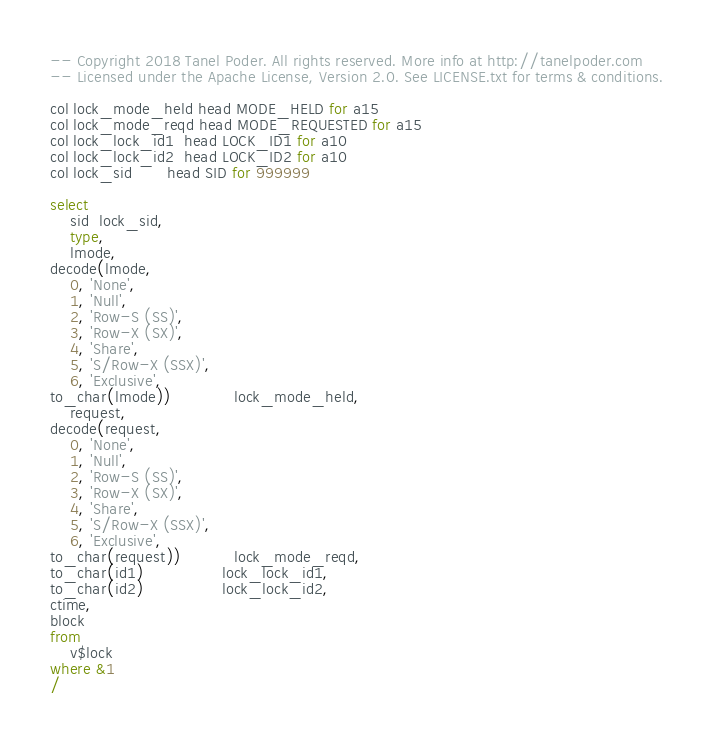Convert code to text. <code><loc_0><loc_0><loc_500><loc_500><_SQL_>-- Copyright 2018 Tanel Poder. All rights reserved. More info at http://tanelpoder.com
-- Licensed under the Apache License, Version 2.0. See LICENSE.txt for terms & conditions.

col lock_mode_held head MODE_HELD for a15
col lock_mode_reqd head MODE_REQUESTED for a15
col lock_lock_id1  head LOCK_ID1 for a10
col lock_lock_id2  head LOCK_ID2 for a10
col lock_sid       head SID for 999999

select 
    sid  lock_sid,
    type,
    lmode,
decode(lmode,
    0, 'None',           
    1, 'Null',           
    2, 'Row-S (SS)',     
    3, 'Row-X (SX)',     
    4, 'Share',          
    5, 'S/Row-X (SSX)',  
    6, 'Exclusive',      
to_char(lmode))             lock_mode_held,
    request,
decode(request,
    0, 'None',           
    1, 'Null',           
    2, 'Row-S (SS)',     
    3, 'Row-X (SX)',     
    4, 'Share',          
    5, 'S/Row-X (SSX)',  
    6, 'Exclusive',      
to_char(request))           lock_mode_reqd,
to_char(id1)                lock_lock_id1, 
to_char(id2)                lock_lock_id2,
ctime,
block
from
    v$lock
where &1
/
</code> 